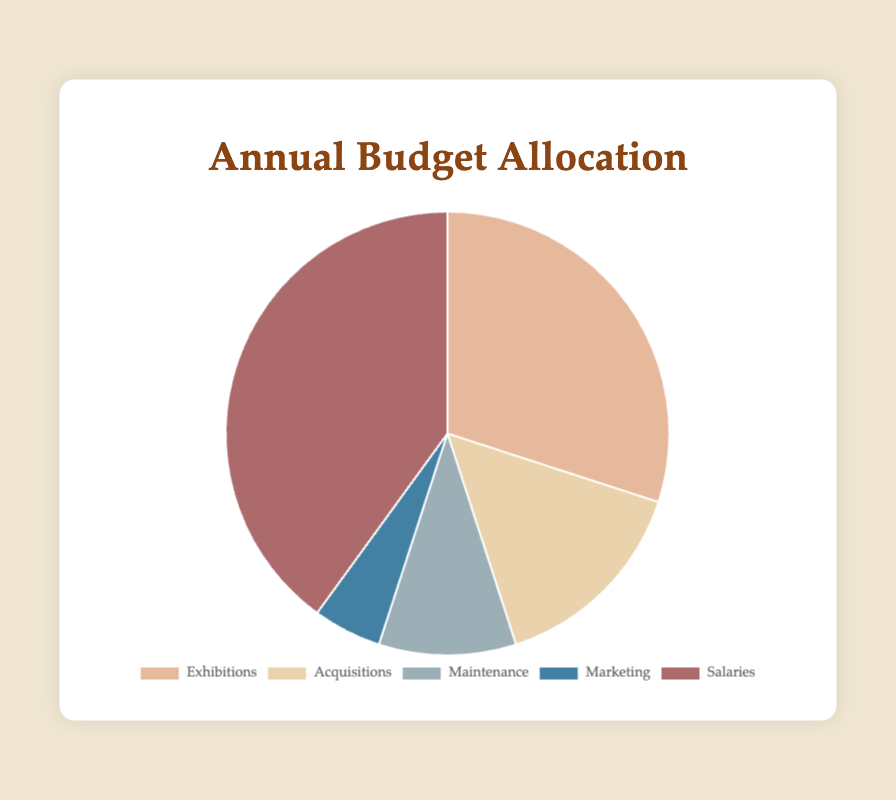What is the total annual budget allocation for the museum? To find the total budget allocation, sum up all the values: Exhibitions (300,000) + Acquisitions (150,000) + Maintenance (100,000) + Marketing (50,000) + Salaries (400,000) = 1,000,000.
Answer: 1,000,000 Which category receives the highest budget allocation? The category with the highest budget allocation is the one with the largest piece in the pie chart. In this case, Salaries receive 400,000, which is the highest amount.
Answer: Salaries How much more is allocated to Exhibitions compared to Marketing? Subtract the budget of Marketing from the budget of Exhibitions: 300,000 (Exhibitions) - 50,000 (Marketing) = 250,000.
Answer: 250,000 What percentage of the total budget is allocated to Acquisitions? First, find the total budget (1,000,000). Then, divide the Acquisitions budget by the total budget and multiply by 100: (150,000 / 1,000,000) * 100 = 15%.
Answer: 15% Which categories have allocations that are less than 100,000 PEN? From the pie chart data, the Maintenance category has a budget of 100,000. Therefore, none of the categories has less than 100,000.
Answer: None What is the combined budget allocation for Exhibitions and Acquisitions? Add the allocations for Exhibitions and Acquisitions: 300,000 (Exhibitions) + 150,000 (Acquisitions) = 450,000.
Answer: 450,000 How does the budget for Salaries compare to the combined budget for Marketing and Maintenance? First, find the combined budget for Marketing and Maintenance: 50,000 (Marketing) + 100,000 (Maintenance) = 150,000. Then compare this to the Salaries budget: 400,000 (Salaries) is greater than 150,000 (combined Marketing and Maintenance).
Answer: Greater Which budget allocation is visually represented by the light blue section of the pie chart? From the visual attributes and the given colors, the light blue section corresponds to Marketing.
Answer: Marketing By how much is the Acquisitions budget larger than the Maintenance budget? Subtract the Maintenance budget from the Acquisitions budget: 150,000 (Acquisitions) - 100,000 (Maintenance) = 50,000.
Answer: 50,000 What is the second-largest allocation category? By comparing the values visually and numerically, the second-largest allocation after Salaries (400,000) is Exhibitions, which receives 300,000.
Answer: Exhibitions 